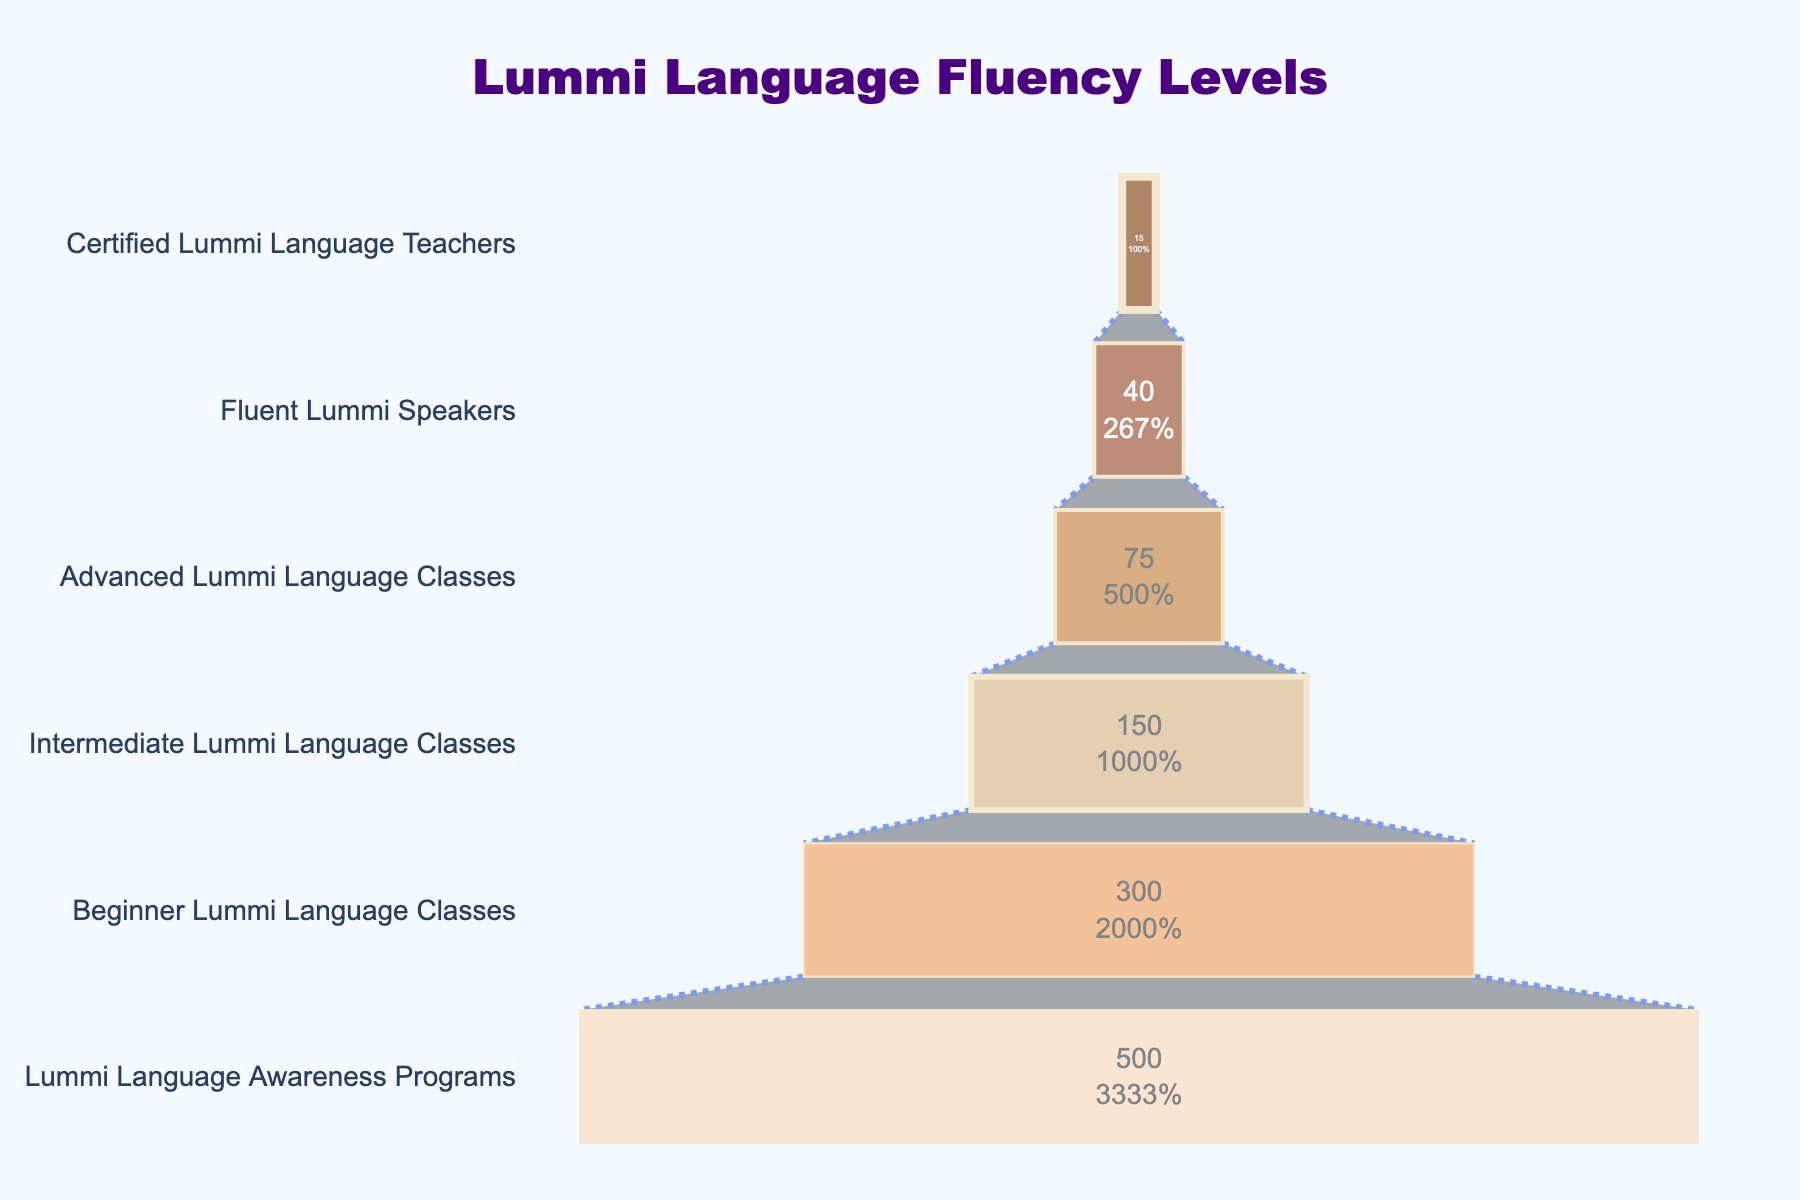How many stages are represented in the funnel chart? There are labeled stages going from "Lummi Language Awareness Programs" to "Certified Lummi Language Teachers". Count the number of those stages.
Answer: 6 Which stage has the highest number of participants? The stage with the largest bar represents the highest number of participants.
Answer: Lummi Language Awareness Programs What percentage of initial participants advanced to the beginner level? Take the number of participants in the beginner stage (300) and divide by the initial participants (500), then multiply by 100%.
Answer: 60% How many participants moved from beginner to intermediate classes? Compare the number of participants in "Beginner Lummi Language Classes" (300) to those in "Intermediate Lummi Language Classes" (150). Subtract the latter from the former.
Answer: 150 What is the cumulative number of participants for intermediate and advanced classes? Add the number of participants in "Intermediate Lummi Language Classes" (150) and in "Advanced Lummi Language Classes" (75).
Answer: 225 Between which two sequential stages is the largest drop in participants observed? Calculate the difference for each sequential pair and identify the largest drop. For example, 500 (awareness) - 300 (beginner) = 200, 300 (beginner) - 150 (intermediate) = 150, etc.
Answer: Lummi Language Awareness Programs to Beginner Lummi Language Classes What is the percentage of participants who become fluent Lummi speakers after completing advanced classes? Divide the number of fluent Lummi speakers (40) by the number of advanced level participants (75), then multiply by 100%.
Answer: Approximately 53.33% Which two stages have the closest number of participants? Compare the number of participants between all adjacent stages and look for the smallest absolute difference. For instance, compare 300 and 150, 150 and 75, etc.
Answer: Advanced Lummi Language Classes and Fluent Lummi Speakers Among certified teachers, what percentage had advanced Lummi fluency? Take the number of certified teachers (15) and divide it by the number of advanced participants (75), then multiply by 100%.
Answer: 20% Which stage shows a smaller decrease in participants: intermediate to advanced or fluent to certified teachers? Calculate the participant decrease between intermediate (150) and advanced (75), which is 75, and between fluent (40) and certified (15), which is 25. Compare the differences: 75 vs 25.
Answer: Fluent to certified teachers 